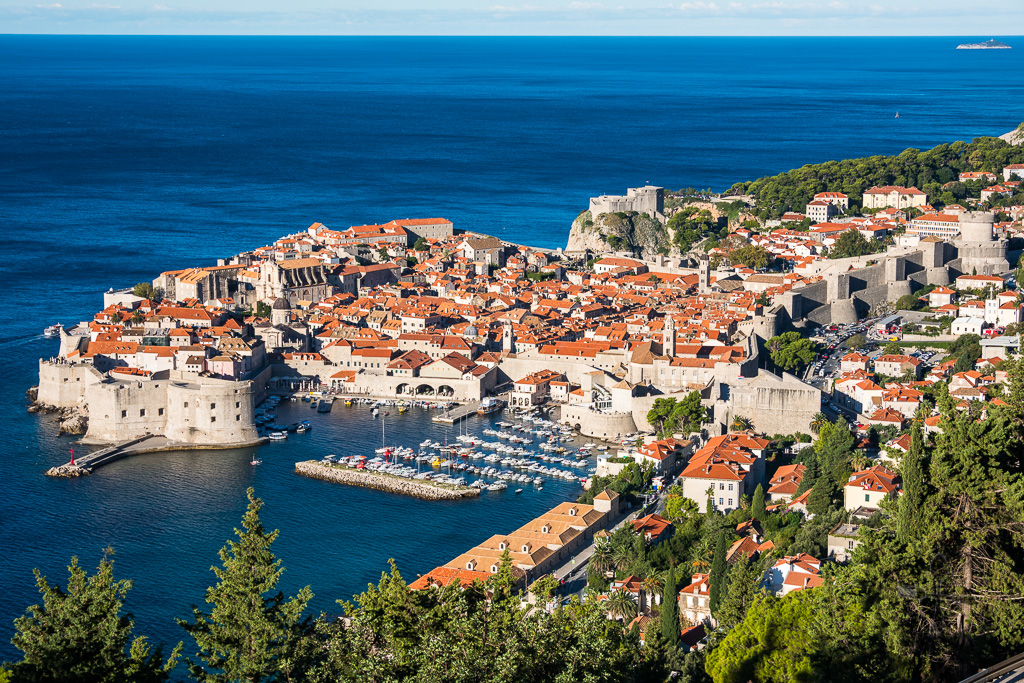A casual visitor might say, 'Wow, the city looks so snug within those walls!' Can you elaborate on this sentiment? Indeed, the city does exude a snug, almost cozy feeling within its formidable walls. This sense of snugness stems from the dense clustering of buildings, the narrow, winding streets, and the intimate courtyards that characterize Dubrovnik's old town. The enclosing stone walls give a sense of security and encapsulation, making the city feel like a well-preserved historical enclave. The harmonious blend of architecture, interspersed with lush greenery and framed by the blue sweep of the Adriatic Sea, adds to the city's charm, making it feel both protected and picturesque. 